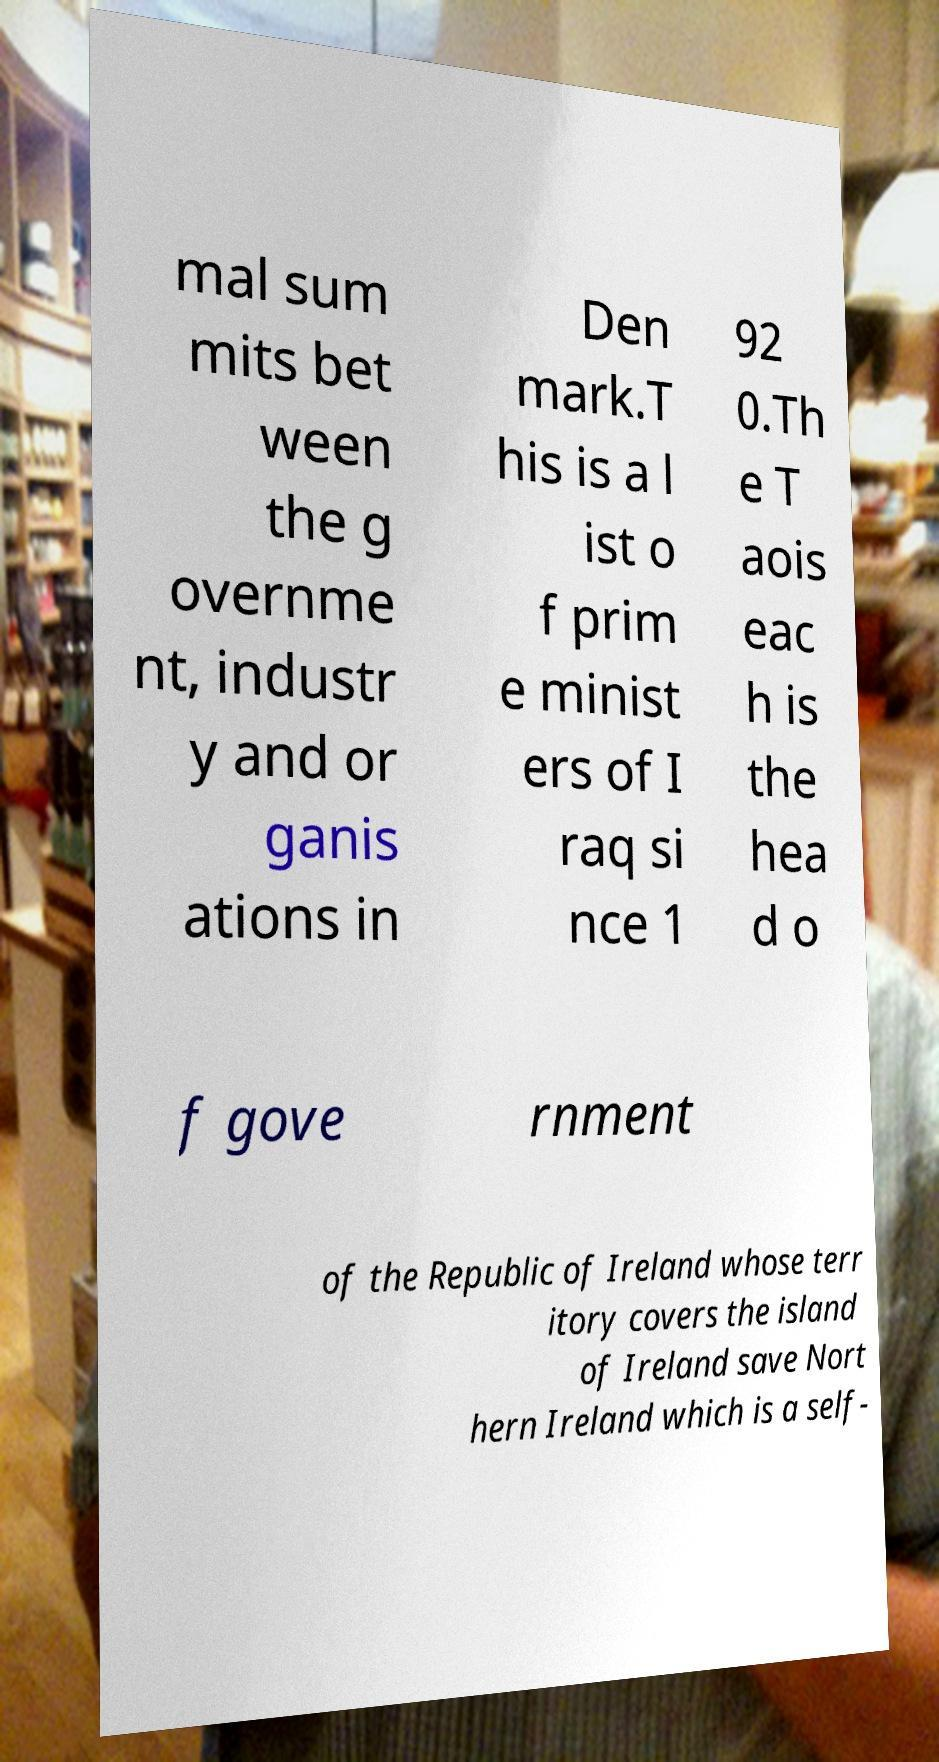Can you read and provide the text displayed in the image?This photo seems to have some interesting text. Can you extract and type it out for me? mal sum mits bet ween the g overnme nt, industr y and or ganis ations in Den mark.T his is a l ist o f prim e minist ers of I raq si nce 1 92 0.Th e T aois eac h is the hea d o f gove rnment of the Republic of Ireland whose terr itory covers the island of Ireland save Nort hern Ireland which is a self- 